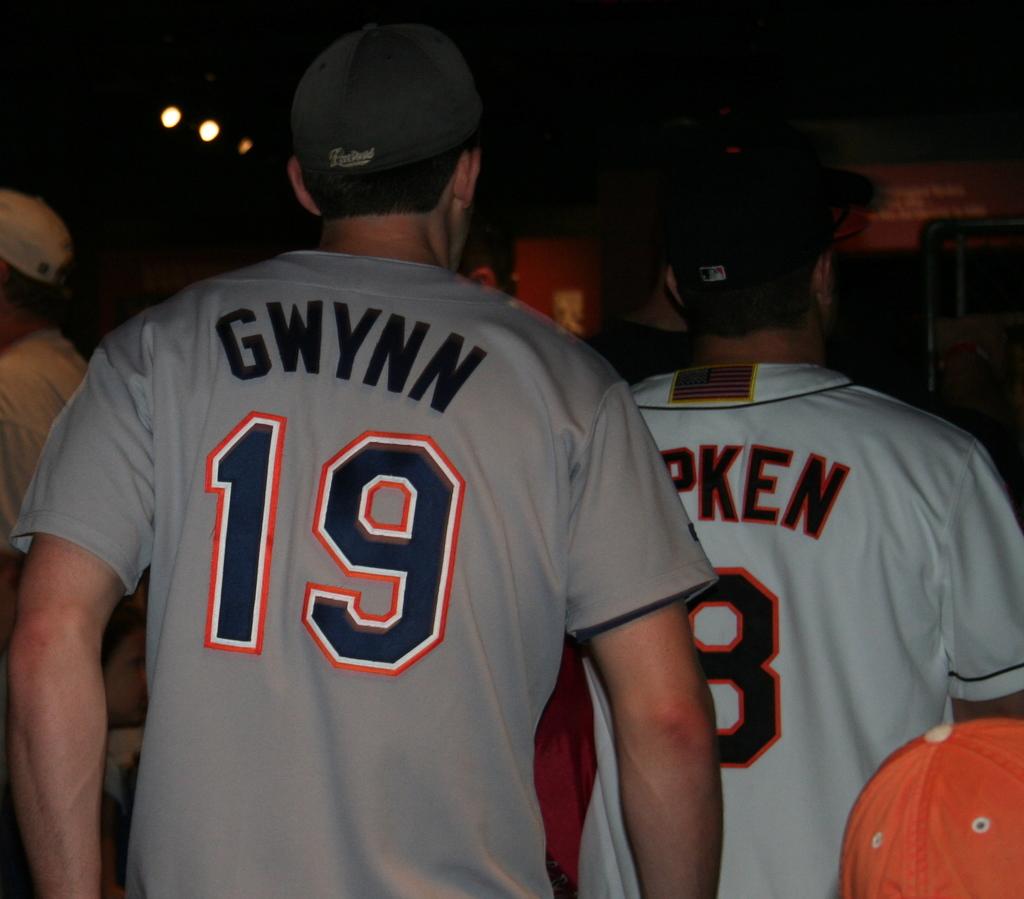What is the name on the grey jersey?
Provide a short and direct response. Gwynn. What number is on the back of the gray t shirt?
Offer a terse response. 19. 